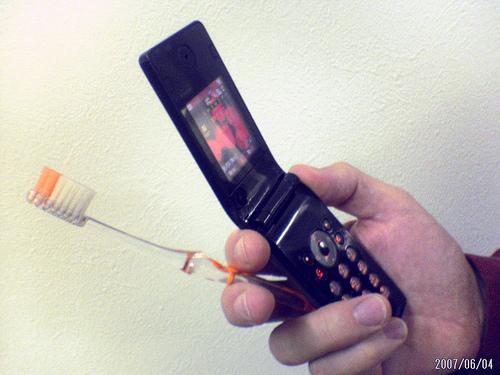What color is the phone?
Give a very brief answer. Black. Is this a new phone?
Quick response, please. No. Is there an electric toothbrush?
Answer briefly. No. Does the person have a cut on his finger?
Give a very brief answer. No. 